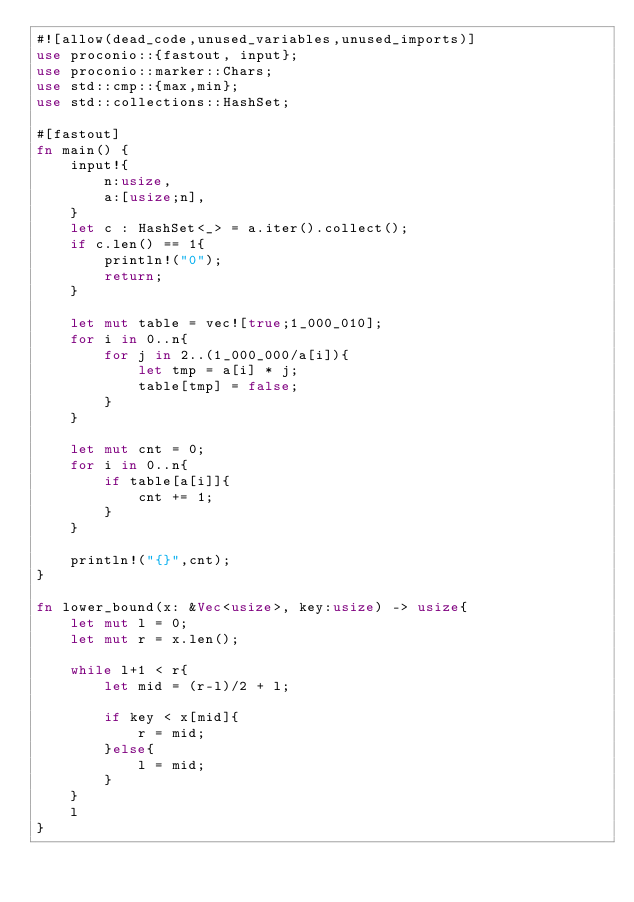<code> <loc_0><loc_0><loc_500><loc_500><_Rust_>#![allow(dead_code,unused_variables,unused_imports)]
use proconio::{fastout, input};
use proconio::marker::Chars;
use std::cmp::{max,min};
use std::collections::HashSet;

#[fastout]
fn main() {
    input!{
        n:usize,
        a:[usize;n],
    }
    let c : HashSet<_> = a.iter().collect();
    if c.len() == 1{
        println!("0");
        return;
    }
    
    let mut table = vec![true;1_000_010];
    for i in 0..n{
        for j in 2..(1_000_000/a[i]){
            let tmp = a[i] * j;
            table[tmp] = false;
        }
    }

    let mut cnt = 0;
    for i in 0..n{
        if table[a[i]]{
            cnt += 1;
        }
    }
    
    println!("{}",cnt);
}

fn lower_bound(x: &Vec<usize>, key:usize) -> usize{
    let mut l = 0;
    let mut r = x.len();

    while l+1 < r{
        let mid = (r-l)/2 + l;

        if key < x[mid]{
            r = mid;
        }else{
            l = mid;
        }
    }
    l
}</code> 